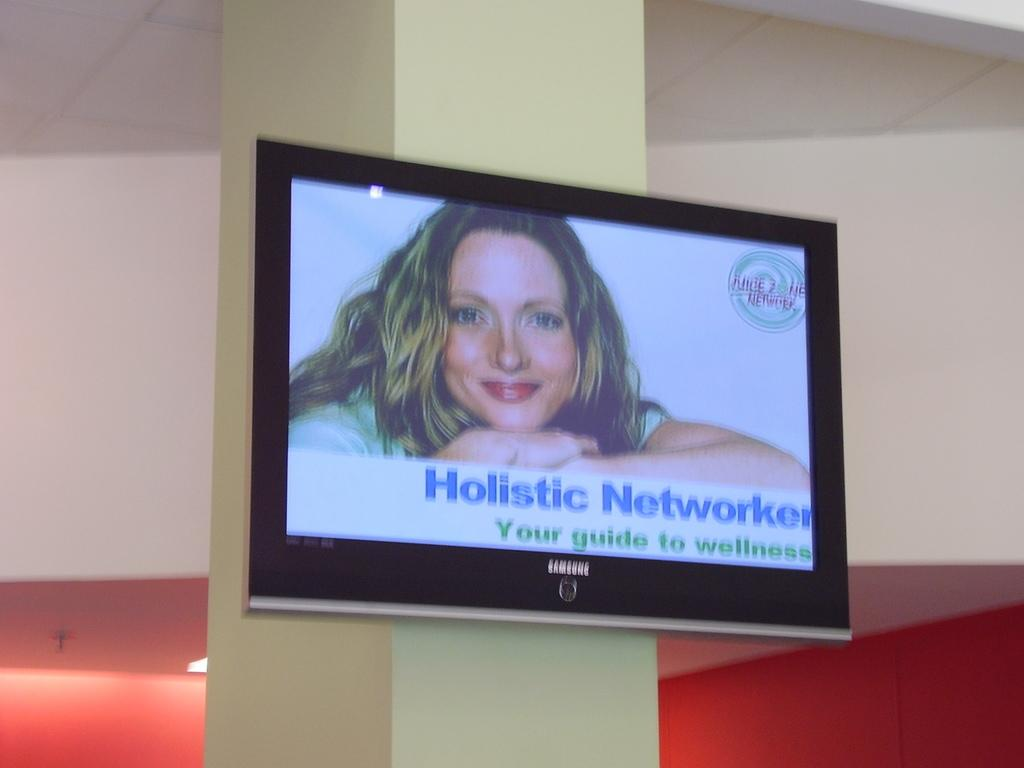<image>
Render a clear and concise summary of the photo. A Samsung TV screen displays a woman known as the Holistic Networker. 